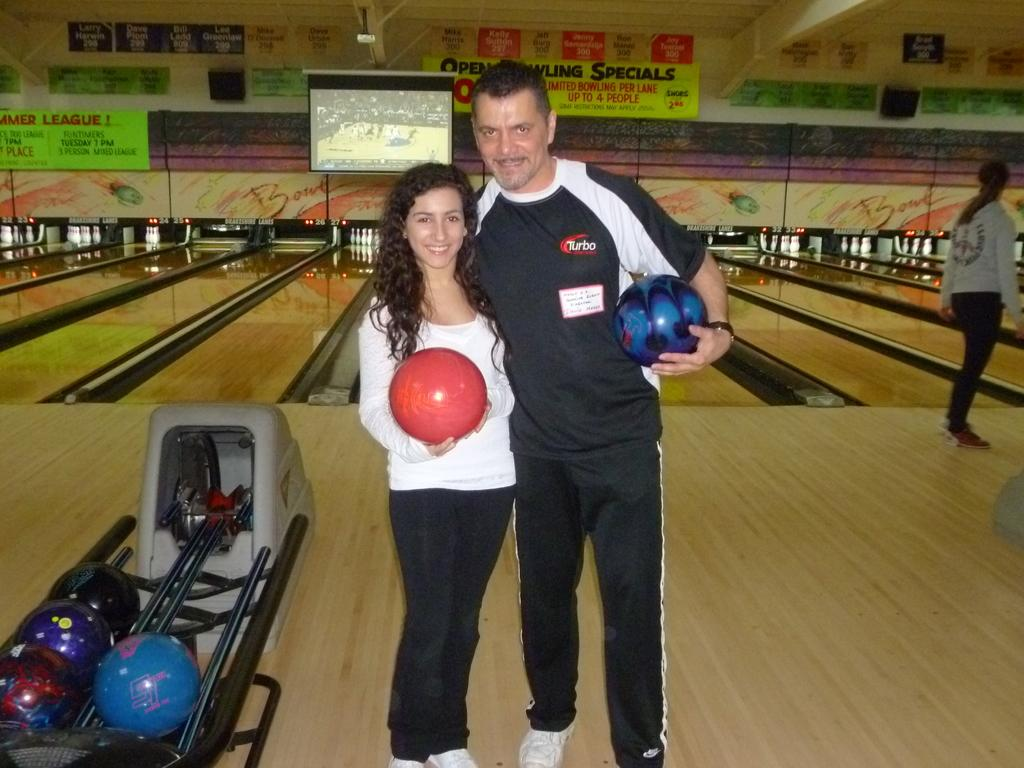Provide a one-sentence caption for the provided image. Man standing next to a woman, holding a bowling ball, and wearing a shirt with the logo Turbo on it. 